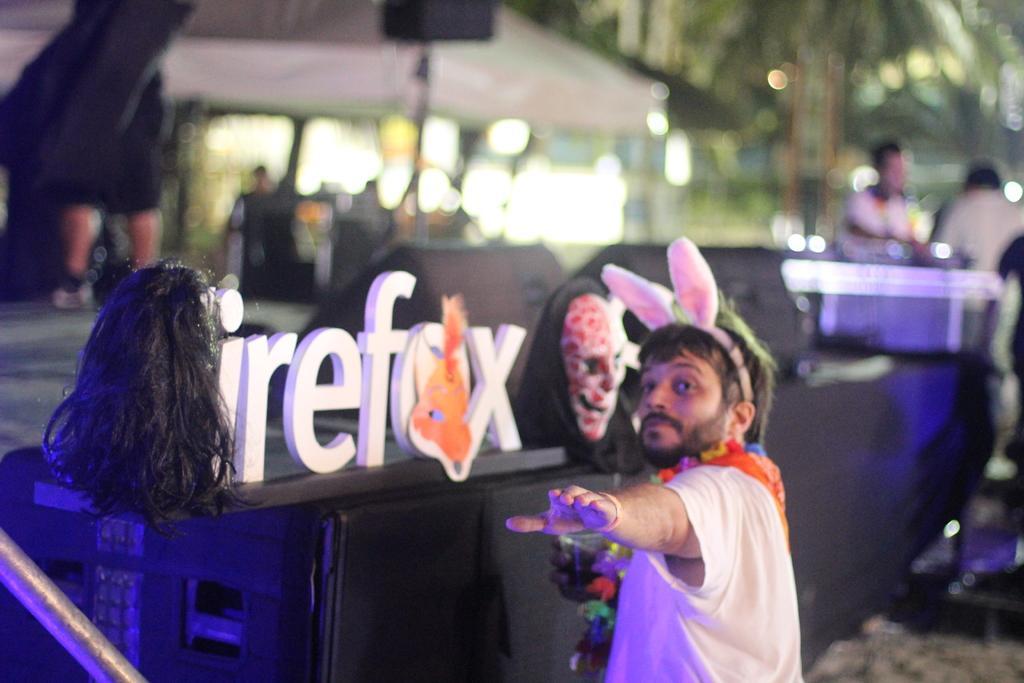How would you summarize this image in a sentence or two? In the center of the image we can see one man is standing and he is smiling, which we can see on his face. And we can see he is in different costume. In front of him, we can see one sign board. On the sign board, we can see two face masks along with the hair. In the bottom left side of the image, we can see one rod. In the background we can see the lights, one building, few people are sitting, few people are standing and a few other objects. 